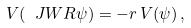Convert formula to latex. <formula><loc_0><loc_0><loc_500><loc_500>V ( \ J W R \psi ) = - r \, V ( \psi ) \, ,</formula> 